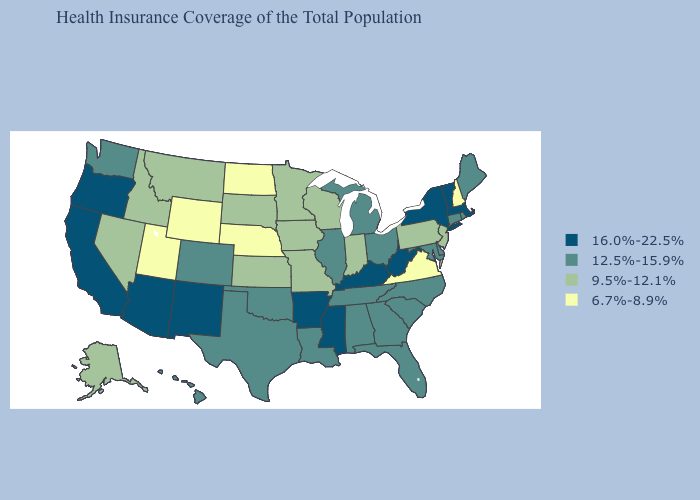What is the lowest value in the USA?
Short answer required. 6.7%-8.9%. Name the states that have a value in the range 12.5%-15.9%?
Quick response, please. Alabama, Colorado, Connecticut, Delaware, Florida, Georgia, Hawaii, Illinois, Louisiana, Maine, Maryland, Michigan, North Carolina, Ohio, Oklahoma, Rhode Island, South Carolina, Tennessee, Texas, Washington. How many symbols are there in the legend?
Be succinct. 4. Does New Hampshire have the highest value in the Northeast?
Short answer required. No. Which states have the lowest value in the South?
Keep it brief. Virginia. Does the first symbol in the legend represent the smallest category?
Give a very brief answer. No. Among the states that border New York , which have the lowest value?
Be succinct. New Jersey, Pennsylvania. Does New Jersey have the lowest value in the Northeast?
Short answer required. No. Does Arizona have the highest value in the USA?
Quick response, please. Yes. Which states have the lowest value in the USA?
Short answer required. Nebraska, New Hampshire, North Dakota, Utah, Virginia, Wyoming. Does the first symbol in the legend represent the smallest category?
Keep it brief. No. Does New Hampshire have the lowest value in the USA?
Write a very short answer. Yes. What is the value of Pennsylvania?
Keep it brief. 9.5%-12.1%. Does Vermont have a higher value than Nebraska?
Answer briefly. Yes. What is the value of South Dakota?
Short answer required. 9.5%-12.1%. 